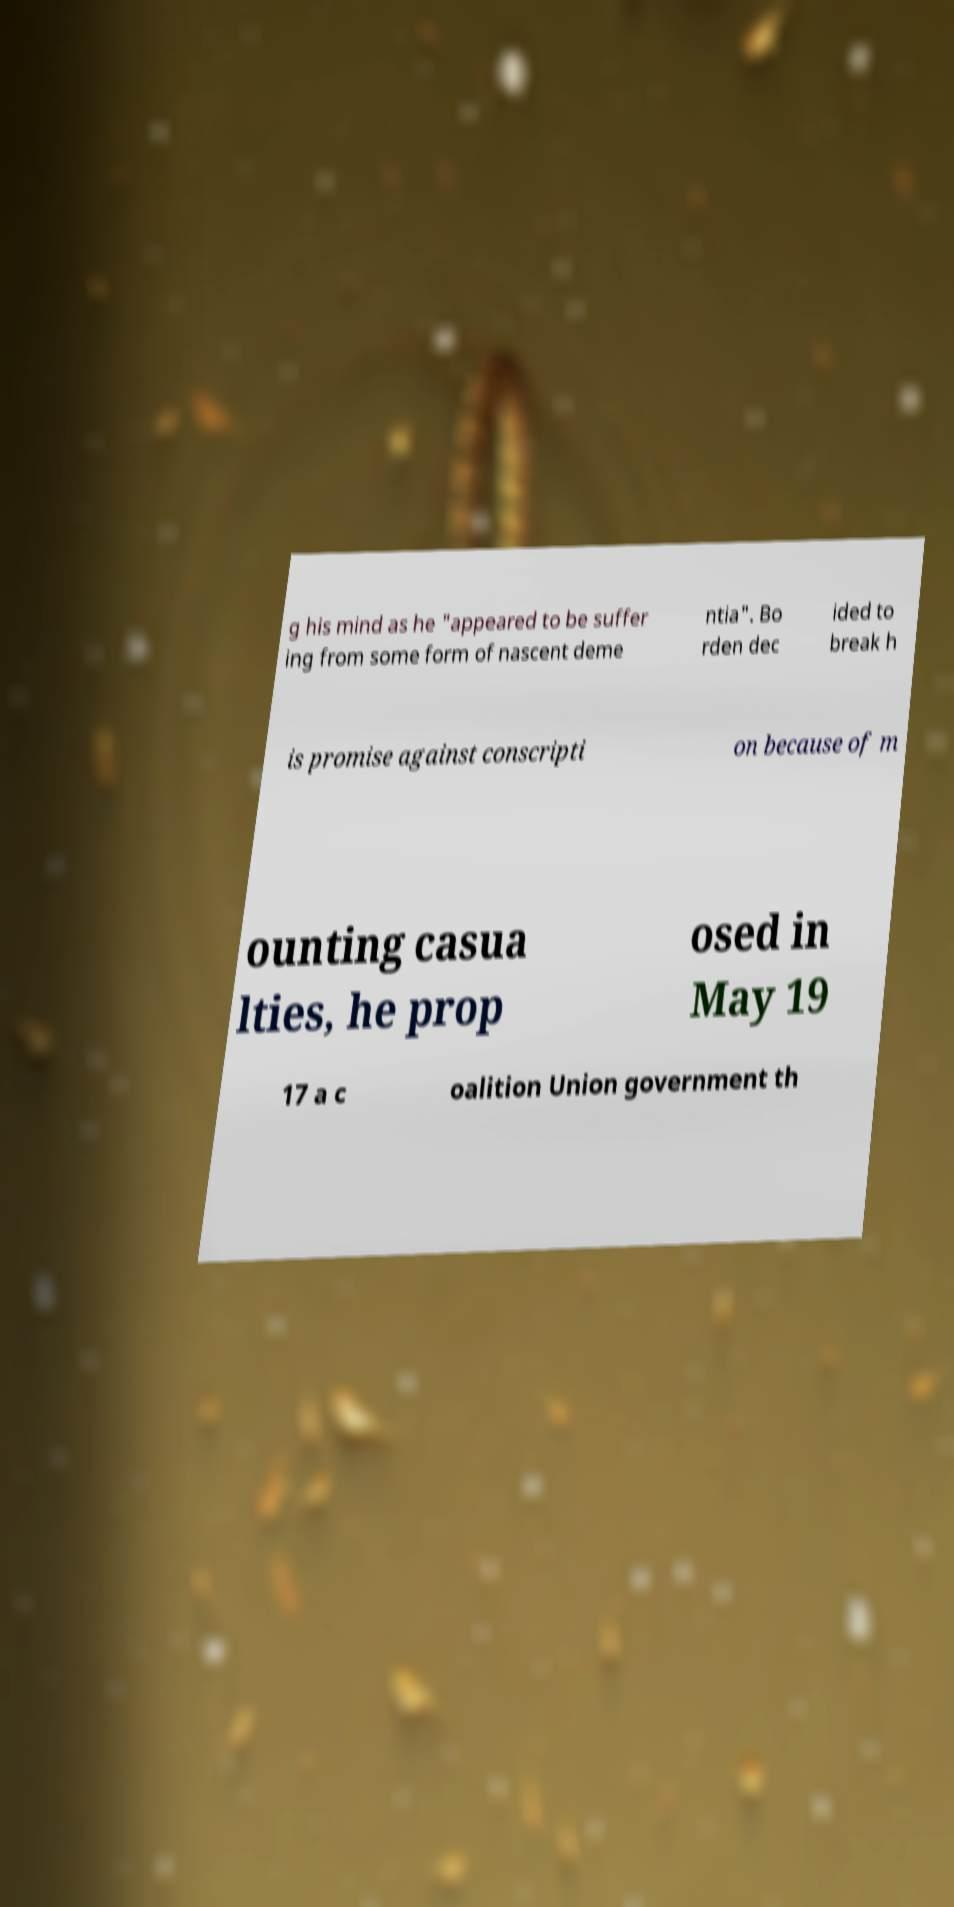Can you accurately transcribe the text from the provided image for me? g his mind as he "appeared to be suffer ing from some form of nascent deme ntia". Bo rden dec ided to break h is promise against conscripti on because of m ounting casua lties, he prop osed in May 19 17 a c oalition Union government th 